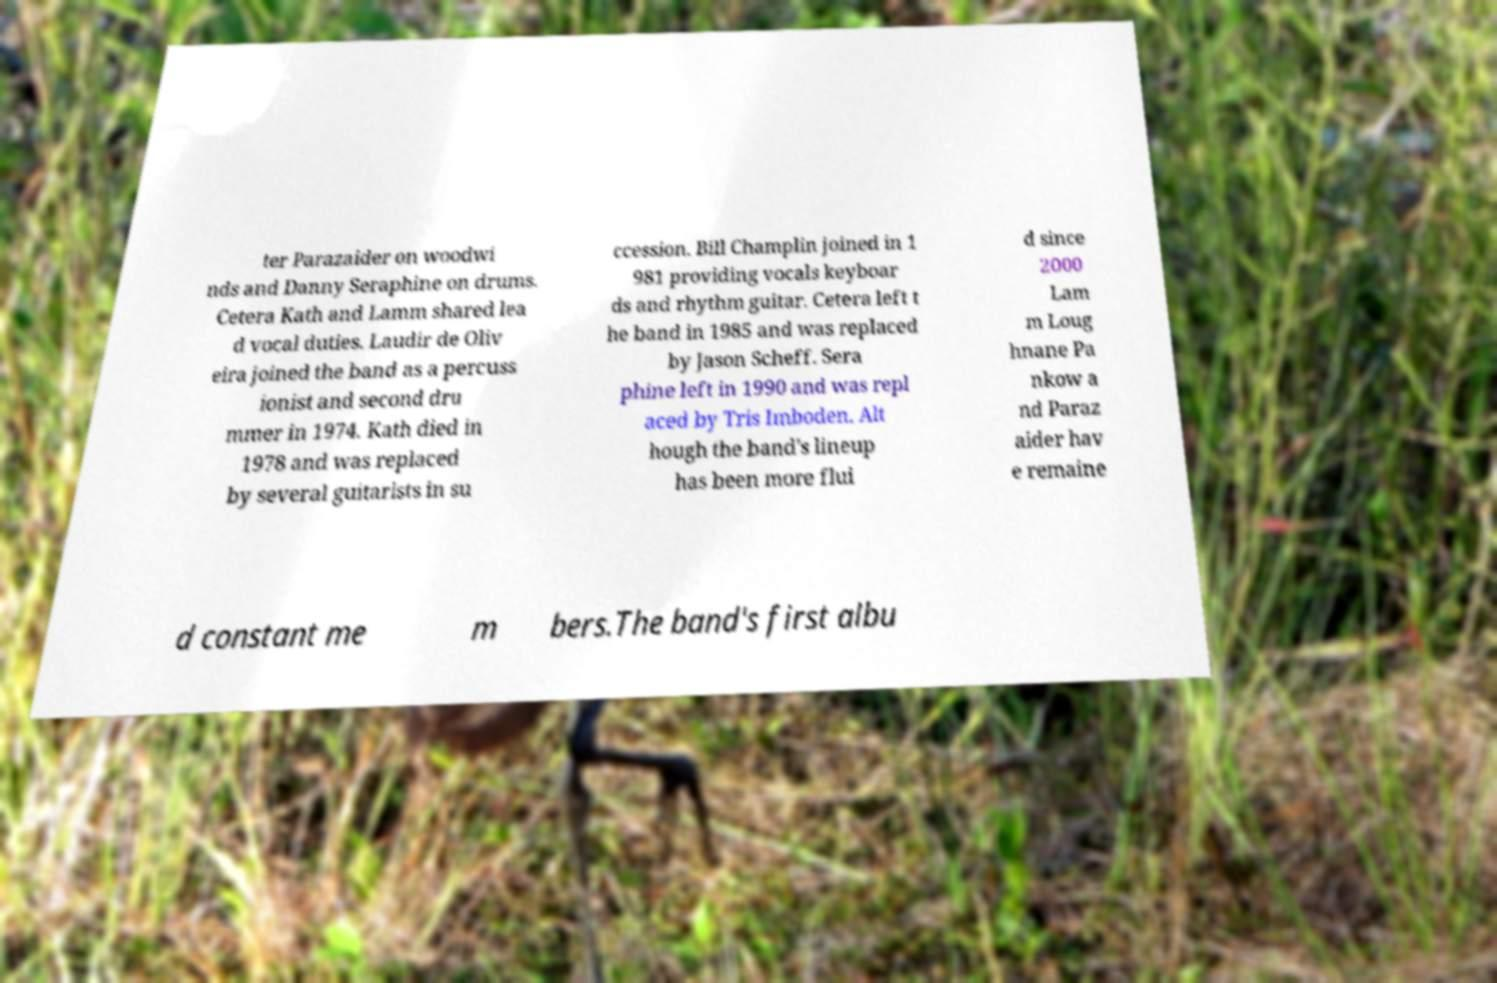Can you accurately transcribe the text from the provided image for me? ter Parazaider on woodwi nds and Danny Seraphine on drums. Cetera Kath and Lamm shared lea d vocal duties. Laudir de Oliv eira joined the band as a percuss ionist and second dru mmer in 1974. Kath died in 1978 and was replaced by several guitarists in su ccession. Bill Champlin joined in 1 981 providing vocals keyboar ds and rhythm guitar. Cetera left t he band in 1985 and was replaced by Jason Scheff. Sera phine left in 1990 and was repl aced by Tris Imboden. Alt hough the band's lineup has been more flui d since 2000 Lam m Loug hnane Pa nkow a nd Paraz aider hav e remaine d constant me m bers.The band's first albu 